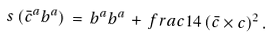Convert formula to latex. <formula><loc_0><loc_0><loc_500><loc_500>s \left ( \bar { c } ^ { a } b ^ { a } \right ) \, = \, b ^ { a } b ^ { a } \, + \, f r a c { 1 } { 4 } \, ( \bar { c } \times c ) ^ { 2 } \, .</formula> 